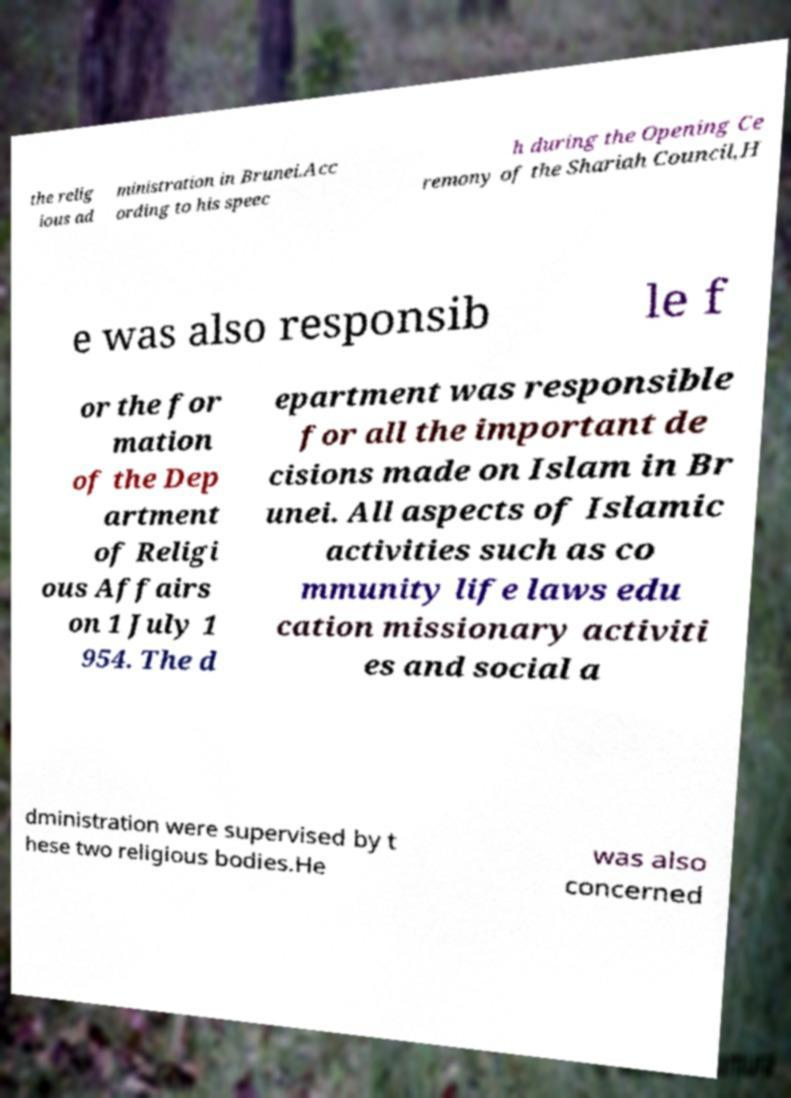Could you assist in decoding the text presented in this image and type it out clearly? the relig ious ad ministration in Brunei.Acc ording to his speec h during the Opening Ce remony of the Shariah Council,H e was also responsib le f or the for mation of the Dep artment of Religi ous Affairs on 1 July 1 954. The d epartment was responsible for all the important de cisions made on Islam in Br unei. All aspects of Islamic activities such as co mmunity life laws edu cation missionary activiti es and social a dministration were supervised by t hese two religious bodies.He was also concerned 